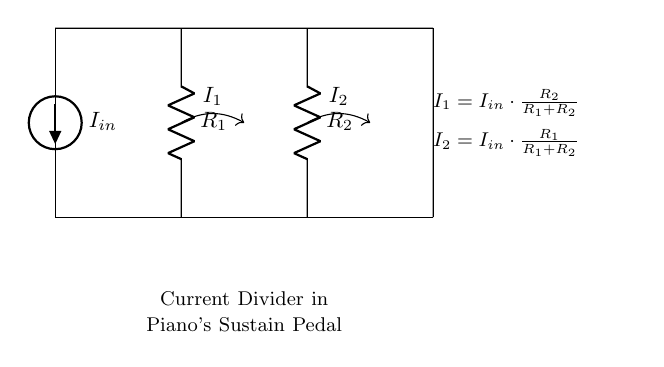What is the input current of the circuit? The input current is denoted as I_in, which is provided by the current source at the top of the circuit.
Answer: I_in What are the values of the resistors in the circuit? The resistors are labeled as R_1 and R_2 in the diagram, but their specific numerical values are not provided in the diagram itself.
Answer: R_1 and R_2 How is current I_1 calculated? Current I_1 is calculated using the formula I_1 = I_in * (R_2 / (R_1 + R_2)), which shows that I_1 is proportional to the input current and the resistance ratio.
Answer: I_in * (R_2 / (R_1 + R_2)) Which current is greater if R_1 is smaller than R_2? If R_1 is smaller than R_2, more current will flow through R_2, making I_1 larger than I_2, since I_1 depends on the proportion of R_2 in the divider ratio.
Answer: I_1 What type of circuit is represented here? The circuit is a current divider circuit, which splits the input current into multiple paths through resistors.
Answer: Current divider What does the notation I_2 represent? I_2 represents the current flowing through resistor R_2, which can be calculated using the formula I_2 = I_in * (R_1 / (R_1 + R_2)).
Answer: I_in * (R_1 / (R_1 + R_2)) If the resistors are equal, what is the relationship between I_1 and I_2? If the resistors R_1 and R_2 are equal, the current is equally divided, meaning I_1 equals I_2. Since the resistors create a symmetrical division in this case, the input current will be halved.
Answer: I_1 = I_2 